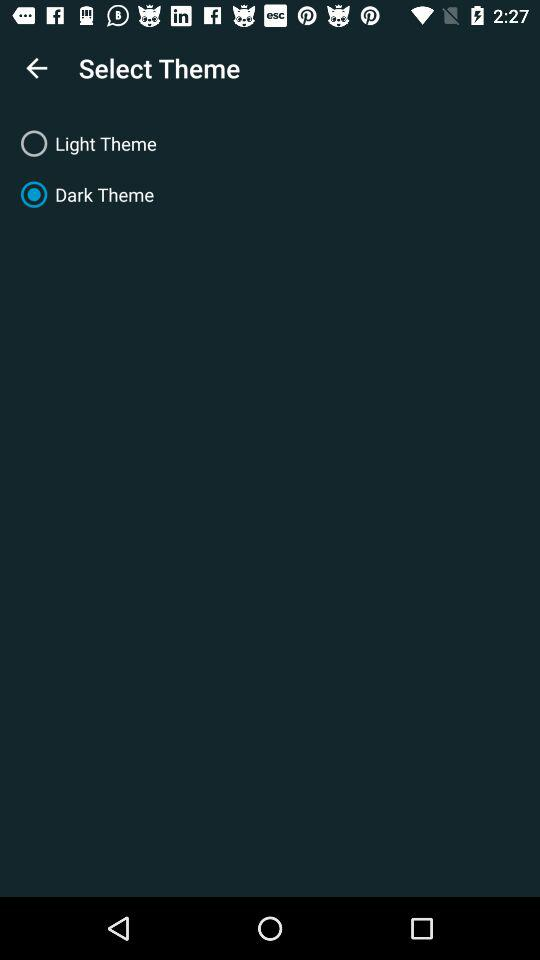What's the selected theme? The selected theme is "Dark Theme". 